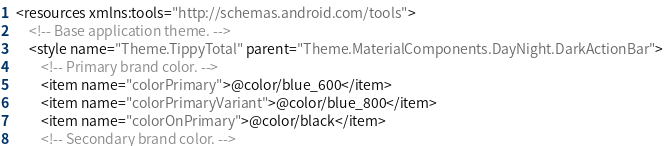<code> <loc_0><loc_0><loc_500><loc_500><_XML_><resources xmlns:tools="http://schemas.android.com/tools">
    <!-- Base application theme. -->
    <style name="Theme.TippyTotal" parent="Theme.MaterialComponents.DayNight.DarkActionBar">
        <!-- Primary brand color. -->
        <item name="colorPrimary">@color/blue_600</item>
        <item name="colorPrimaryVariant">@color/blue_800</item>
        <item name="colorOnPrimary">@color/black</item>
        <!-- Secondary brand color. --></code> 